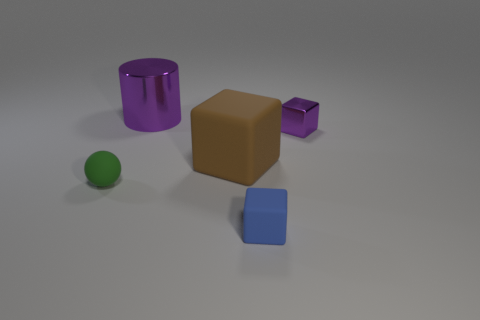Add 4 small cyan rubber objects. How many objects exist? 9 Subtract all cubes. How many objects are left? 2 Subtract all small things. Subtract all small gray rubber things. How many objects are left? 2 Add 2 big matte things. How many big matte things are left? 3 Add 3 rubber blocks. How many rubber blocks exist? 5 Subtract 0 cyan cylinders. How many objects are left? 5 